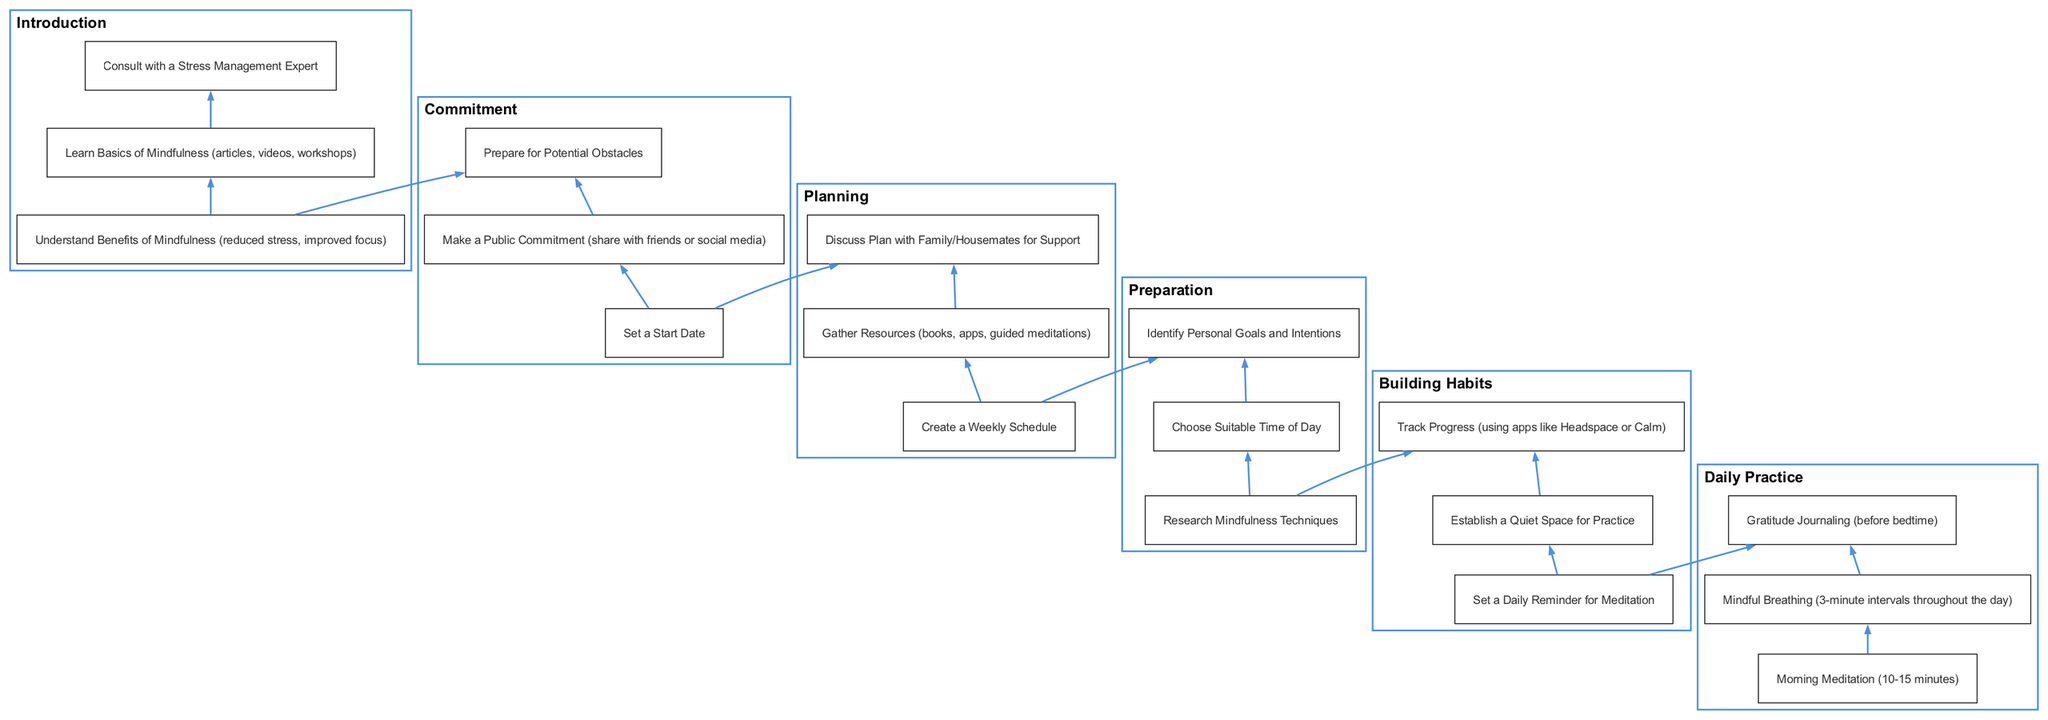What is the title of Stage 3? The title of Stage 3 is located in the diagram, which is labeled under "Preparation". This can be found as the third stage from the bottom.
Answer: Preparation How many components are listed in Stage 2? To find the number of components in Stage 2, we look under the title "Building Habits" and count the listed components, which are three in total.
Answer: 3 What are the first two components of Stage 4? Reviewing the components listed under Stage 4 titled "Planning", we identify the first two components as "Create a Weekly Schedule" and "Gather Resources (books, apps, guided meditations)". They are listed sequentially within the stage.
Answer: Create a Weekly Schedule, Gather Resources (books, apps, guided meditations) Which stage involves understanding the benefits of mindfulness? The understanding of the benefits of mindfulness is discussed under Stage 6, where the components focus on understanding the benefits, learning basics, and consulting an expert. This makes it clear that this understanding comes first in the sequence.
Answer: Stage 6 Which stage comes directly before Commitment? In the flow of the diagram, Commitment is Stage 5, and it comes directly after Stage 4, which is Planning. The relationship between these stages shows a clear sequential flow from Planning to Commitment.
Answer: Stage 4 What is the relationship between Stage 1 and Stage 2? Stage 1, titled "Daily Practice", directly follows Stage 2, "Building Habits" in the flow. This indicates that to engage in daily practices, one must first establish habits that support those practices.
Answer: Stage 2 is before Stage 1 How many total stages are presented in this mindfulness routine diagram? By examining the diagram, we note the numbered stages from Stage 1 through Stage 6, which totals six distinct stages highlighted in the flowchart.
Answer: 6 In which stage is tracking progress mentioned? Tracking progress is found in Stage 2, specifically listed as one of the components under "Building Habits". This indicates it is an essential part of establishing habits related to mindfulness practice.
Answer: Stage 2 What is the last component listed in Stage 5? The last component under Stage 5, titled "Commitment", is "Prepare for Potential Obstacles". This is the final point in the stage that helps ensure readiness for challenges.
Answer: Prepare for Potential Obstacles 